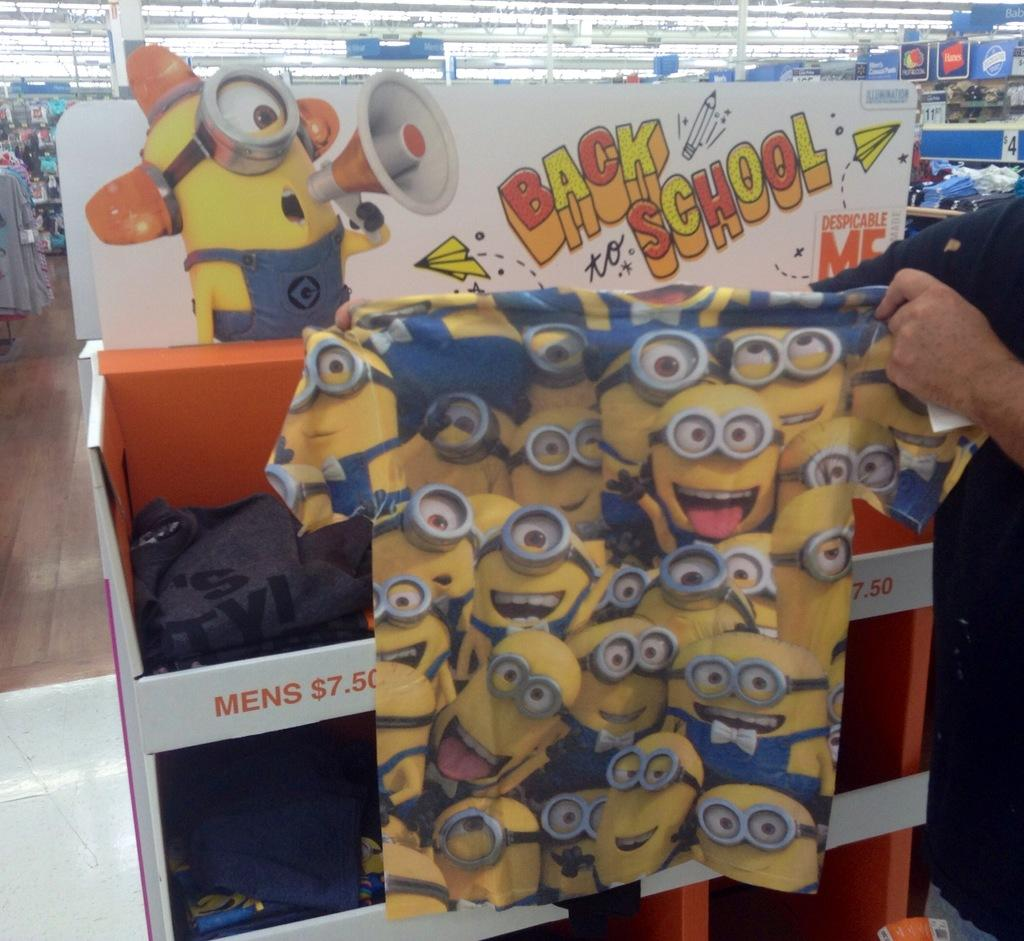Who is present in the image? There is a person in the image. What is the person holding in the image? The person is holding a shirt. What can be seen in the background of the image? There are clothes and boards visible in the background of the image. What is the structure visible at the top of the image? There is a roof visible at the top of the image. What type of square is being washed by the person in the image? There is no square or washing activity present in the image. 